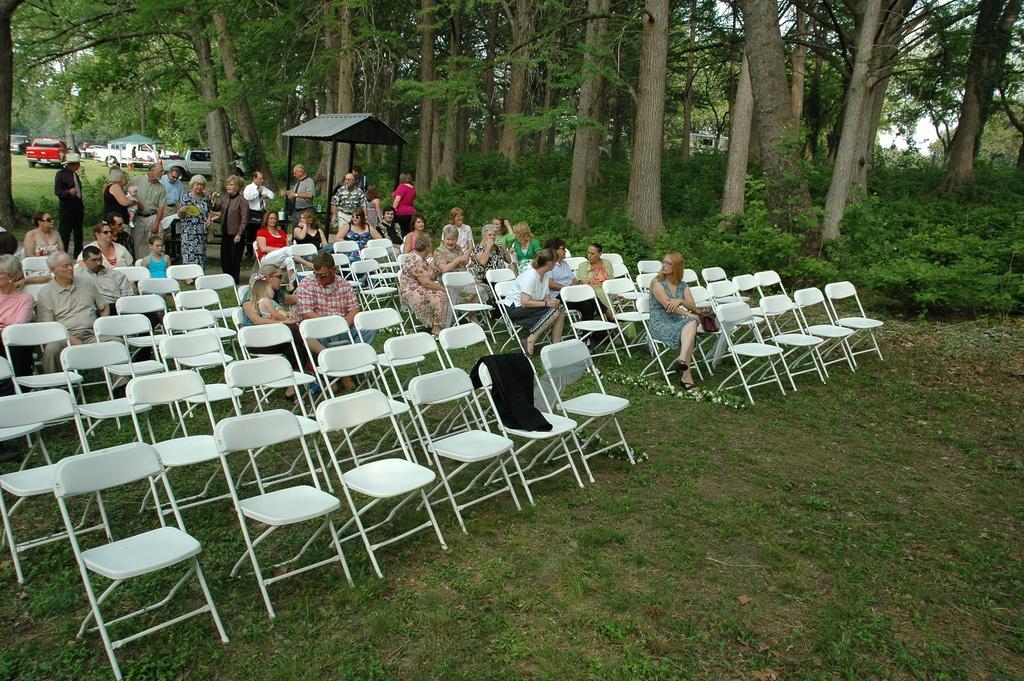In one or two sentences, can you explain what this image depicts? In this image few chairs are arranged in an order. Few group of members are sitting on chairs and few are standing at the backside of it on a grassy land. Few plants and trees are at the background of the image. At the left side there are few vehicles are there. 